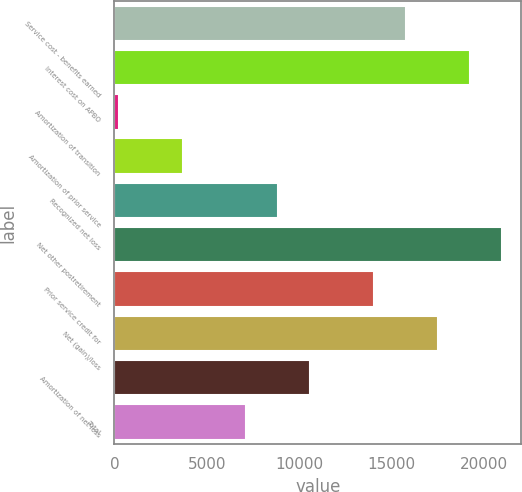Convert chart to OTSL. <chart><loc_0><loc_0><loc_500><loc_500><bar_chart><fcel>Service cost - benefits earned<fcel>Interest cost on APBO<fcel>Amortization of transition<fcel>Amortization of prior service<fcel>Recognized net loss<fcel>Net other postretirement<fcel>Prior service credit for<fcel>Net (gain)/loss<fcel>Amortization of net loss<fcel>Total<nl><fcel>15799.9<fcel>19258.1<fcel>238<fcel>3696.2<fcel>8883.5<fcel>20987.2<fcel>14070.8<fcel>17529<fcel>10612.6<fcel>7154.4<nl></chart> 